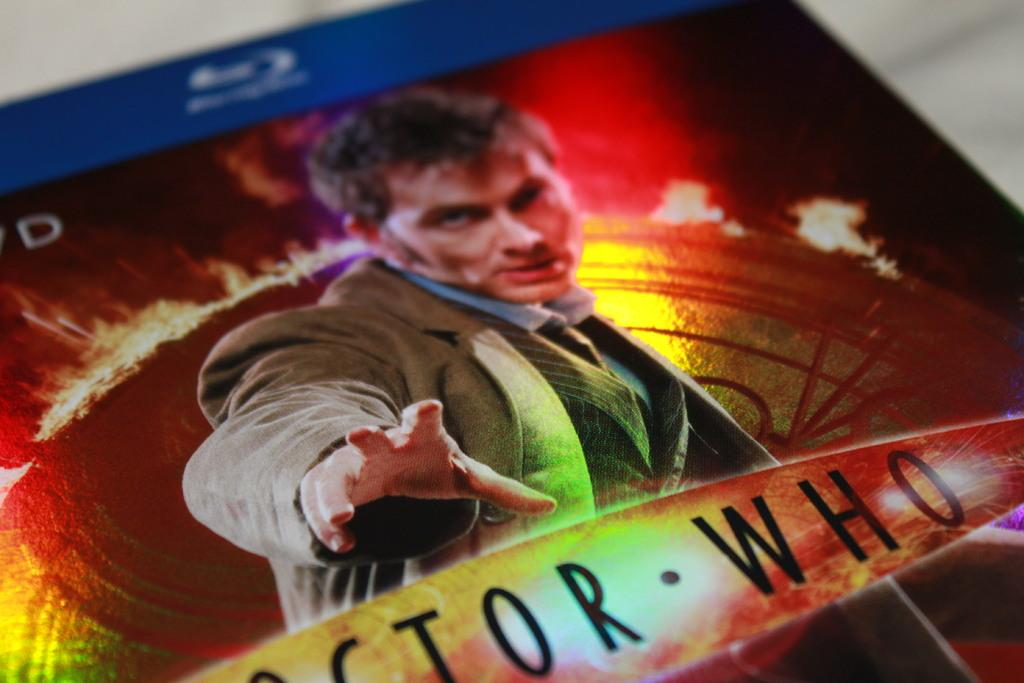Provide a one-sentence caption for the provided image. A Blu Ray disc of the Doctor Who series with the character on the front. 